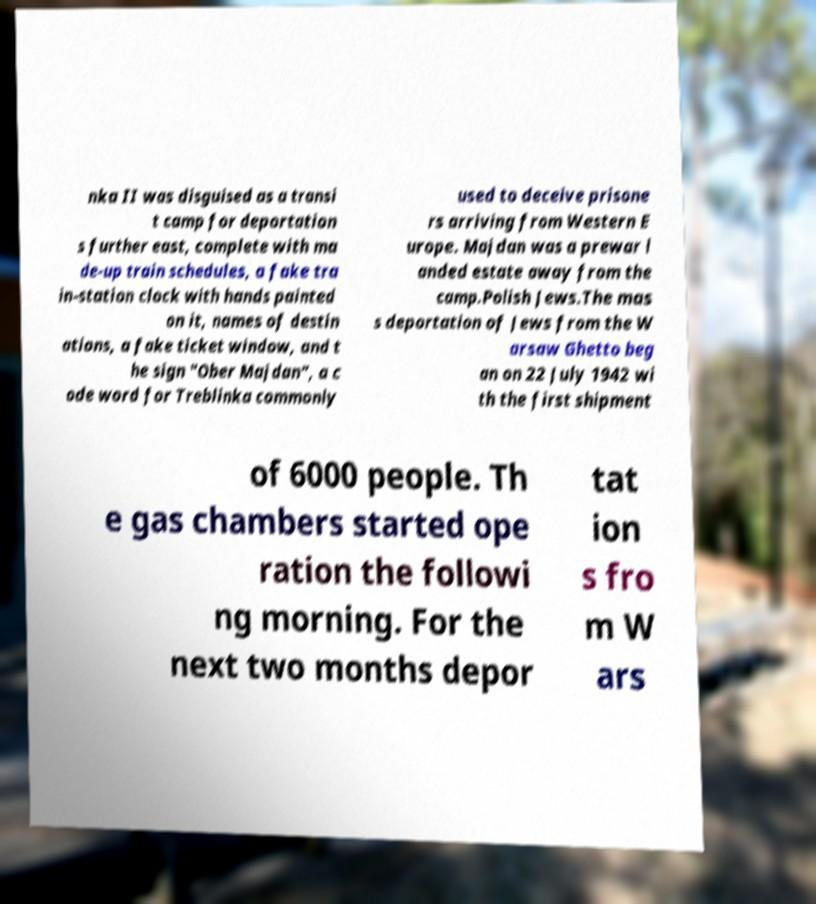Could you assist in decoding the text presented in this image and type it out clearly? nka II was disguised as a transi t camp for deportation s further east, complete with ma de-up train schedules, a fake tra in-station clock with hands painted on it, names of destin ations, a fake ticket window, and t he sign "Ober Majdan", a c ode word for Treblinka commonly used to deceive prisone rs arriving from Western E urope. Majdan was a prewar l anded estate away from the camp.Polish Jews.The mas s deportation of Jews from the W arsaw Ghetto beg an on 22 July 1942 wi th the first shipment of 6000 people. Th e gas chambers started ope ration the followi ng morning. For the next two months depor tat ion s fro m W ars 